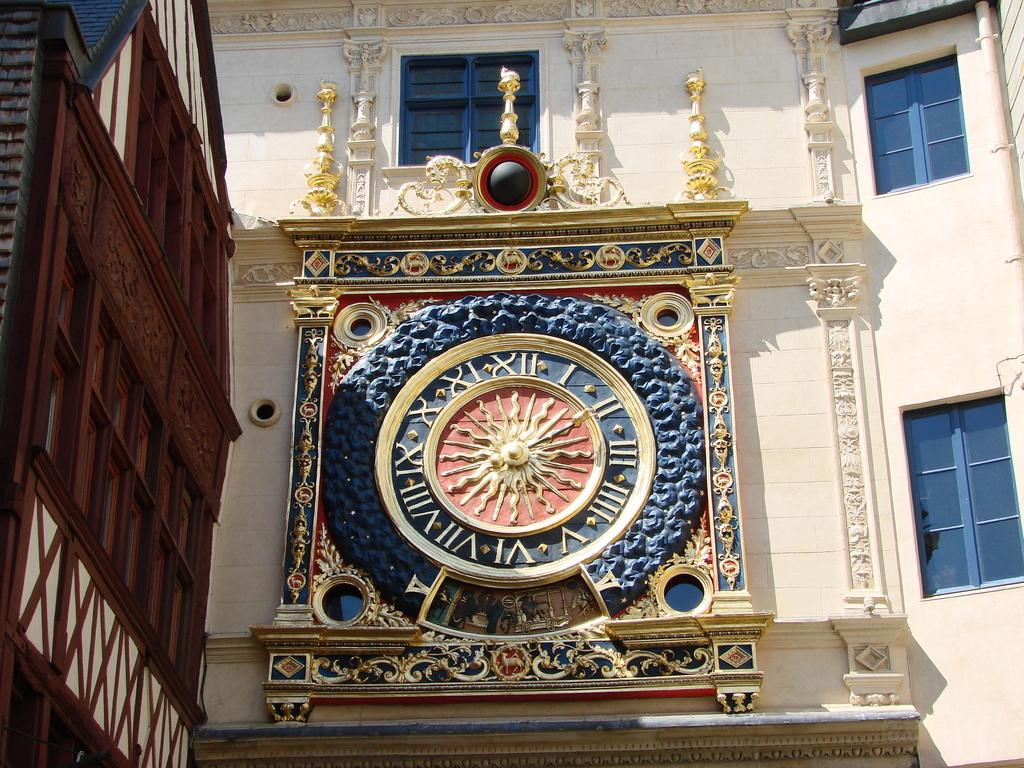What type of structure can be seen in the image? There are walls visible in the image, suggesting a structure. Can you identify any specific objects on the walls? Yes, there is a clock on a wall in the image. What can be seen through the windows in the image? The presence of windows in the image implies that there is a view of the outside, but the specifics cannot be determined from the provided facts. Where is the birth of the newborn baby taking place in the image? There is no indication of a birth or a baby in the image; it only features walls, a clock, and windows. 